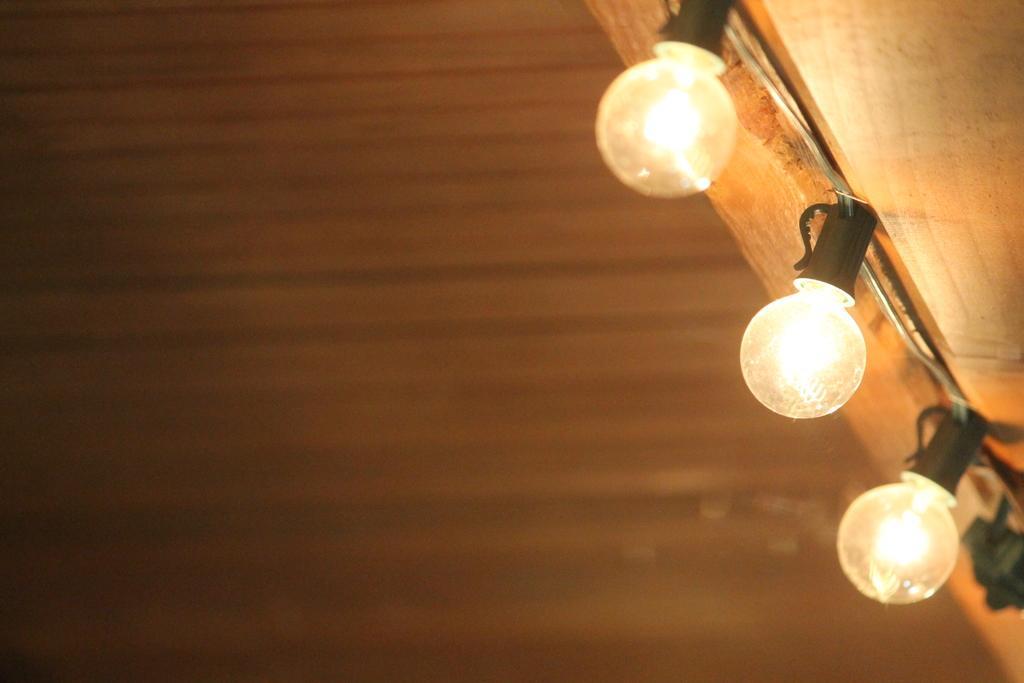Can you describe this image briefly? In this image, we can see lights on the blur background. 